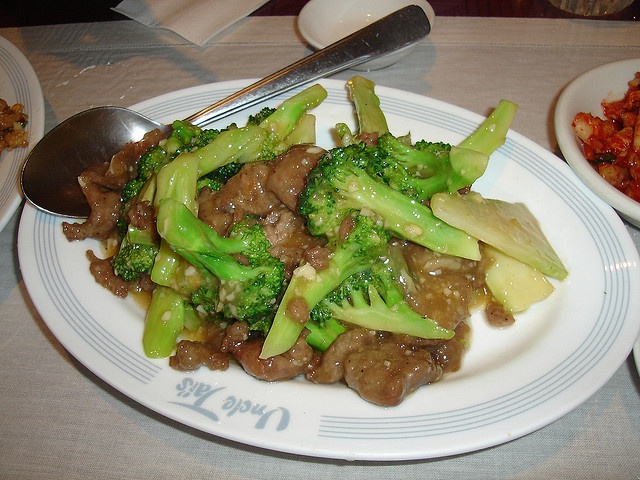Describe the objects in this image and their specific colors. I can see dining table in black, darkgray, and gray tones, spoon in black, gray, maroon, and darkgray tones, broccoli in black and olive tones, bowl in black, darkgray, maroon, and gray tones, and broccoli in black, olive, and darkgreen tones in this image. 